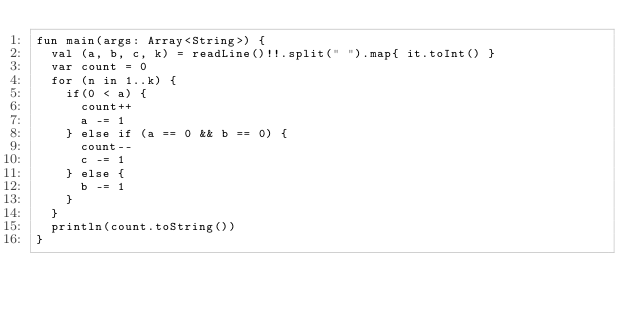<code> <loc_0><loc_0><loc_500><loc_500><_Kotlin_>fun main(args: Array<String>) {
  val (a, b, c, k) = readLine()!!.split(" ").map{ it.toInt() }
  var count = 0
  for (n in 1..k) {
    if(0 < a) {
      count++
      a -= 1
    } else if (a == 0 && b == 0) {
      count--
      c -= 1
    } else {
      b -= 1
    }
  }
  println(count.toString())
}</code> 